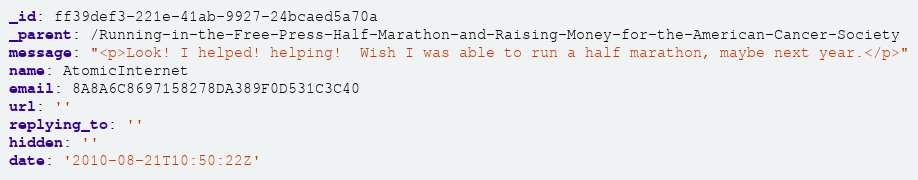<code> <loc_0><loc_0><loc_500><loc_500><_YAML_>_id: ff39def3-221e-41ab-9927-24bcaed5a70a
_parent: /Running-in-the-Free-Press-Half-Marathon-and-Raising-Money-for-the-American-Cancer-Society
message: "<p>Look! I helped! helping!  Wish I was able to run a half marathon, maybe next year.</p>"
name: AtomicInternet
email: 8A8A6C8697158278DA389F0D531C3C40
url: ''
replying_to: ''
hidden: ''
date: '2010-08-21T10:50:22Z'</code> 